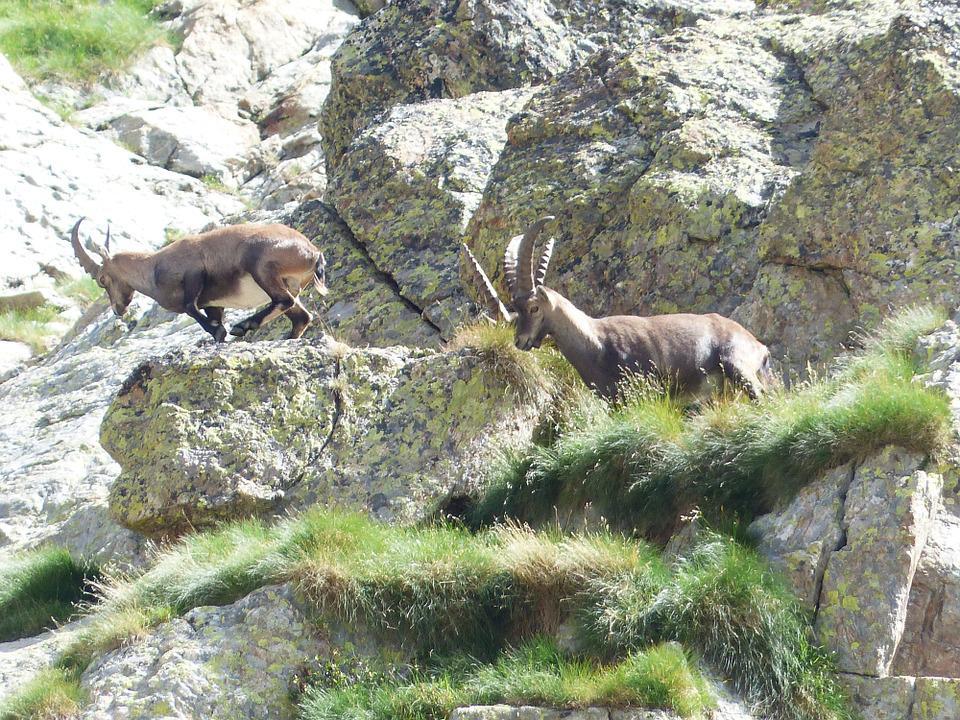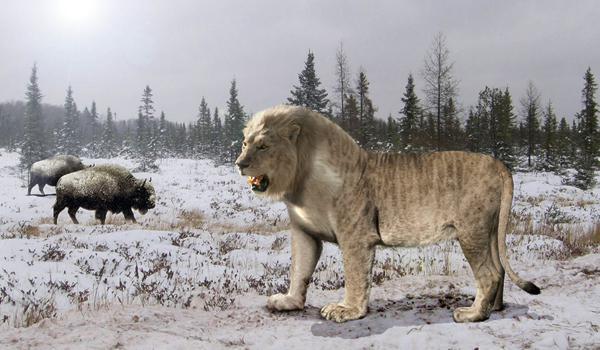The first image is the image on the left, the second image is the image on the right. Examine the images to the left and right. Is the description "One animal with curved horns is laying on the ground and one animal is standing at the peak of something." accurate? Answer yes or no. No. 